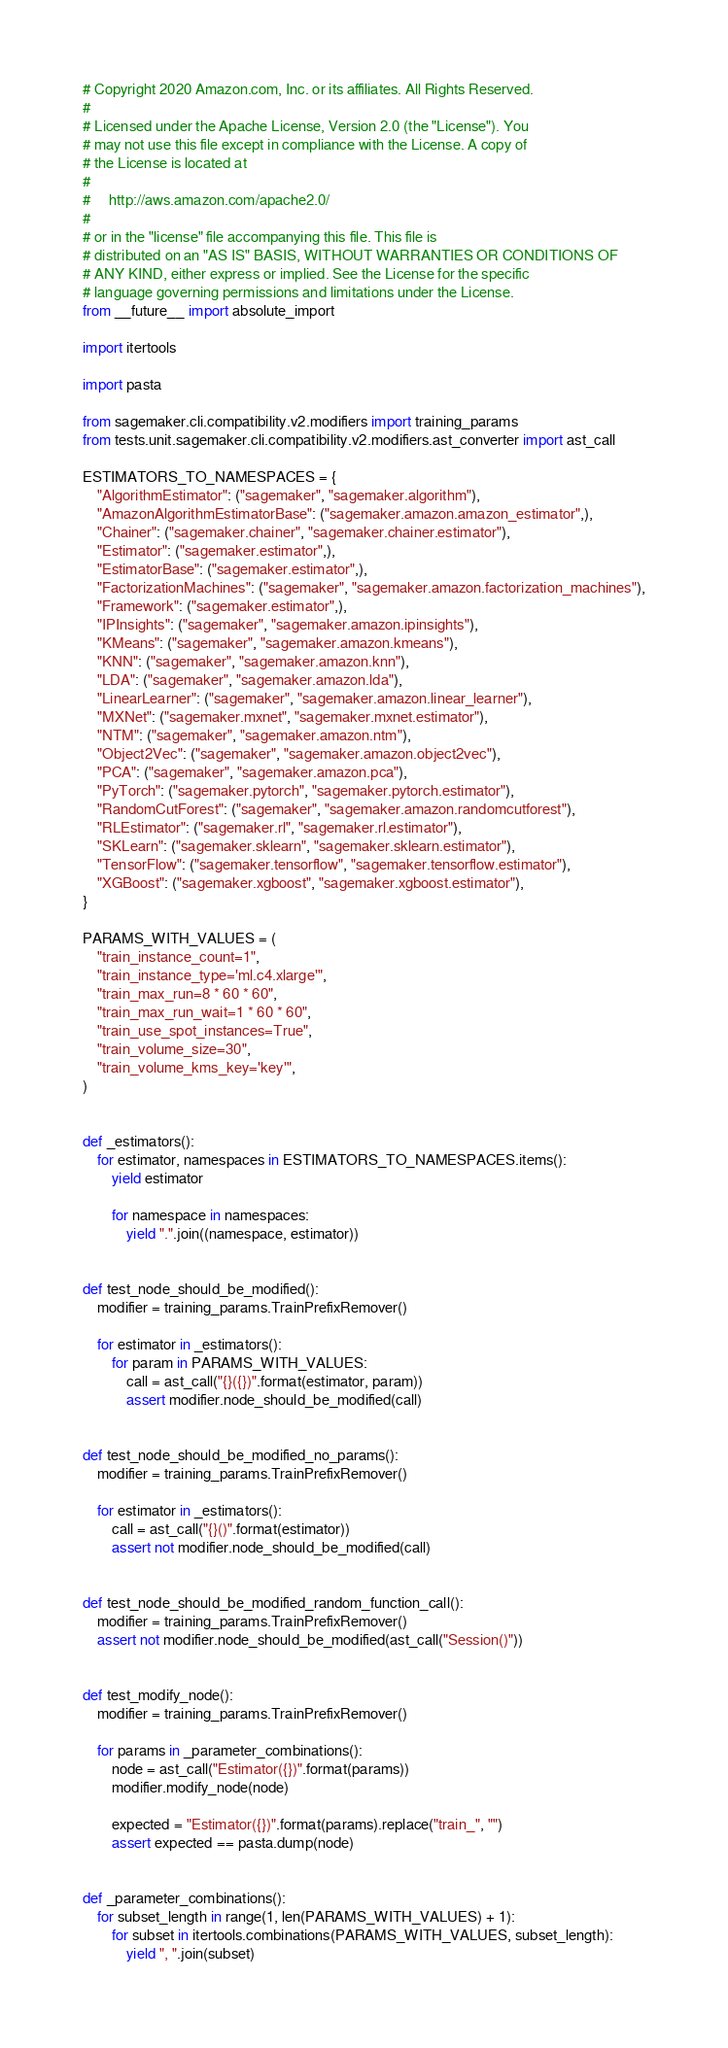Convert code to text. <code><loc_0><loc_0><loc_500><loc_500><_Python_># Copyright 2020 Amazon.com, Inc. or its affiliates. All Rights Reserved.
#
# Licensed under the Apache License, Version 2.0 (the "License"). You
# may not use this file except in compliance with the License. A copy of
# the License is located at
#
#     http://aws.amazon.com/apache2.0/
#
# or in the "license" file accompanying this file. This file is
# distributed on an "AS IS" BASIS, WITHOUT WARRANTIES OR CONDITIONS OF
# ANY KIND, either express or implied. See the License for the specific
# language governing permissions and limitations under the License.
from __future__ import absolute_import

import itertools

import pasta

from sagemaker.cli.compatibility.v2.modifiers import training_params
from tests.unit.sagemaker.cli.compatibility.v2.modifiers.ast_converter import ast_call

ESTIMATORS_TO_NAMESPACES = {
    "AlgorithmEstimator": ("sagemaker", "sagemaker.algorithm"),
    "AmazonAlgorithmEstimatorBase": ("sagemaker.amazon.amazon_estimator",),
    "Chainer": ("sagemaker.chainer", "sagemaker.chainer.estimator"),
    "Estimator": ("sagemaker.estimator",),
    "EstimatorBase": ("sagemaker.estimator",),
    "FactorizationMachines": ("sagemaker", "sagemaker.amazon.factorization_machines"),
    "Framework": ("sagemaker.estimator",),
    "IPInsights": ("sagemaker", "sagemaker.amazon.ipinsights"),
    "KMeans": ("sagemaker", "sagemaker.amazon.kmeans"),
    "KNN": ("sagemaker", "sagemaker.amazon.knn"),
    "LDA": ("sagemaker", "sagemaker.amazon.lda"),
    "LinearLearner": ("sagemaker", "sagemaker.amazon.linear_learner"),
    "MXNet": ("sagemaker.mxnet", "sagemaker.mxnet.estimator"),
    "NTM": ("sagemaker", "sagemaker.amazon.ntm"),
    "Object2Vec": ("sagemaker", "sagemaker.amazon.object2vec"),
    "PCA": ("sagemaker", "sagemaker.amazon.pca"),
    "PyTorch": ("sagemaker.pytorch", "sagemaker.pytorch.estimator"),
    "RandomCutForest": ("sagemaker", "sagemaker.amazon.randomcutforest"),
    "RLEstimator": ("sagemaker.rl", "sagemaker.rl.estimator"),
    "SKLearn": ("sagemaker.sklearn", "sagemaker.sklearn.estimator"),
    "TensorFlow": ("sagemaker.tensorflow", "sagemaker.tensorflow.estimator"),
    "XGBoost": ("sagemaker.xgboost", "sagemaker.xgboost.estimator"),
}

PARAMS_WITH_VALUES = (
    "train_instance_count=1",
    "train_instance_type='ml.c4.xlarge'",
    "train_max_run=8 * 60 * 60",
    "train_max_run_wait=1 * 60 * 60",
    "train_use_spot_instances=True",
    "train_volume_size=30",
    "train_volume_kms_key='key'",
)


def _estimators():
    for estimator, namespaces in ESTIMATORS_TO_NAMESPACES.items():
        yield estimator

        for namespace in namespaces:
            yield ".".join((namespace, estimator))


def test_node_should_be_modified():
    modifier = training_params.TrainPrefixRemover()

    for estimator in _estimators():
        for param in PARAMS_WITH_VALUES:
            call = ast_call("{}({})".format(estimator, param))
            assert modifier.node_should_be_modified(call)


def test_node_should_be_modified_no_params():
    modifier = training_params.TrainPrefixRemover()

    for estimator in _estimators():
        call = ast_call("{}()".format(estimator))
        assert not modifier.node_should_be_modified(call)


def test_node_should_be_modified_random_function_call():
    modifier = training_params.TrainPrefixRemover()
    assert not modifier.node_should_be_modified(ast_call("Session()"))


def test_modify_node():
    modifier = training_params.TrainPrefixRemover()

    for params in _parameter_combinations():
        node = ast_call("Estimator({})".format(params))
        modifier.modify_node(node)

        expected = "Estimator({})".format(params).replace("train_", "")
        assert expected == pasta.dump(node)


def _parameter_combinations():
    for subset_length in range(1, len(PARAMS_WITH_VALUES) + 1):
        for subset in itertools.combinations(PARAMS_WITH_VALUES, subset_length):
            yield ", ".join(subset)
</code> 